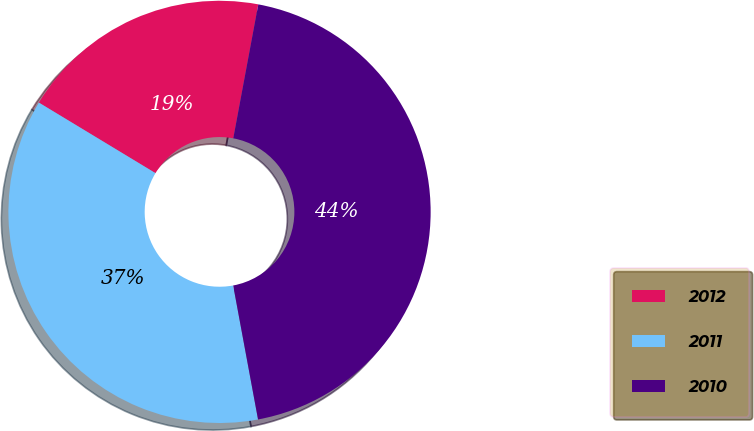<chart> <loc_0><loc_0><loc_500><loc_500><pie_chart><fcel>2012<fcel>2011<fcel>2010<nl><fcel>19.28%<fcel>36.58%<fcel>44.14%<nl></chart> 